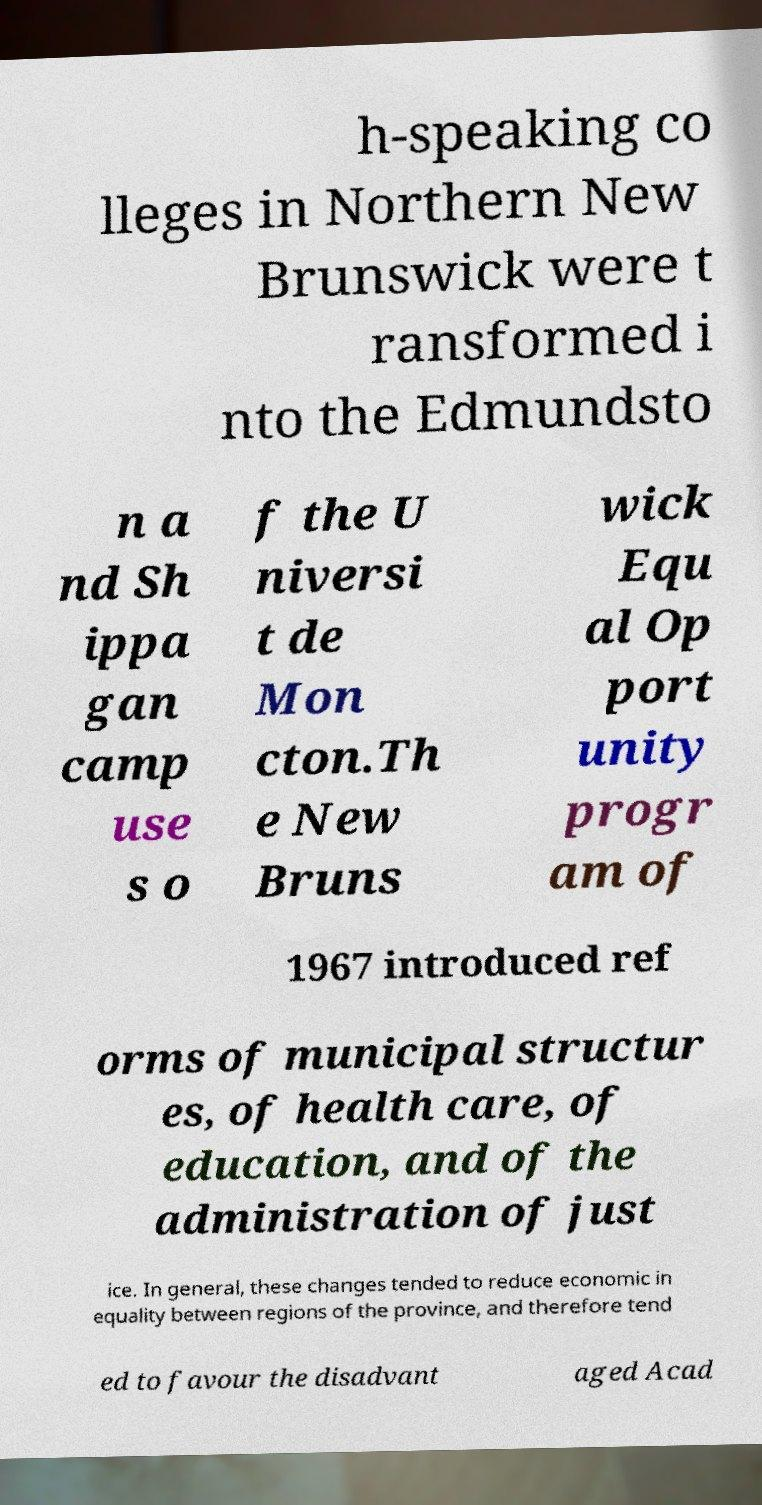What messages or text are displayed in this image? I need them in a readable, typed format. h-speaking co lleges in Northern New Brunswick were t ransformed i nto the Edmundsto n a nd Sh ippa gan camp use s o f the U niversi t de Mon cton.Th e New Bruns wick Equ al Op port unity progr am of 1967 introduced ref orms of municipal structur es, of health care, of education, and of the administration of just ice. In general, these changes tended to reduce economic in equality between regions of the province, and therefore tend ed to favour the disadvant aged Acad 